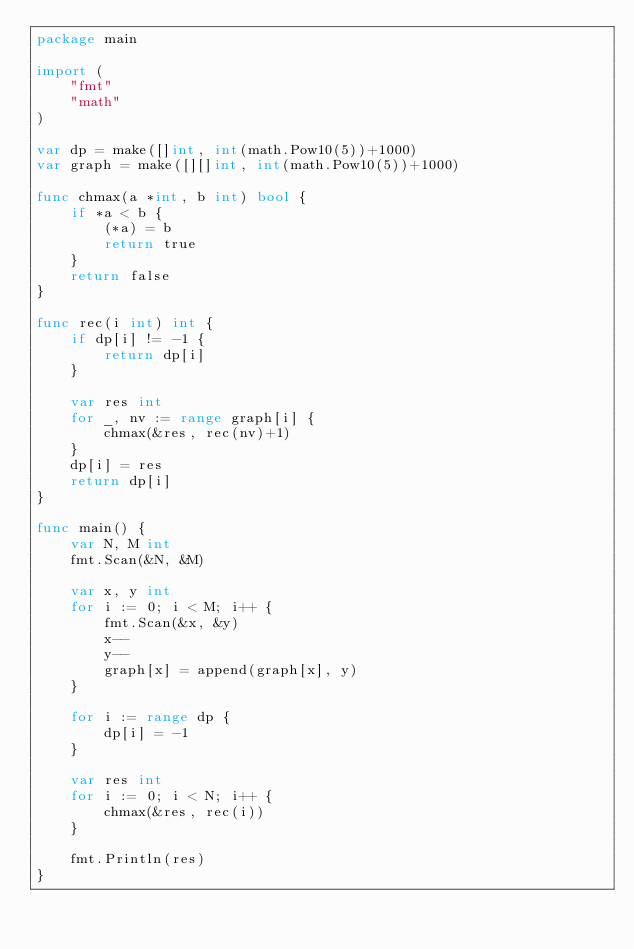Convert code to text. <code><loc_0><loc_0><loc_500><loc_500><_Go_>package main

import (
	"fmt"
	"math"
)

var dp = make([]int, int(math.Pow10(5))+1000)
var graph = make([][]int, int(math.Pow10(5))+1000)

func chmax(a *int, b int) bool {
	if *a < b {
		(*a) = b
		return true
	}
	return false
}

func rec(i int) int {
	if dp[i] != -1 {
		return dp[i]
	}

	var res int
	for _, nv := range graph[i] {
		chmax(&res, rec(nv)+1)
	}
	dp[i] = res
	return dp[i]
}

func main() {
	var N, M int
	fmt.Scan(&N, &M)

	var x, y int
	for i := 0; i < M; i++ {
		fmt.Scan(&x, &y)
		x--
		y--
		graph[x] = append(graph[x], y)
	}

	for i := range dp {
		dp[i] = -1
	}

	var res int
	for i := 0; i < N; i++ {
		chmax(&res, rec(i))
	}

	fmt.Println(res)
}</code> 